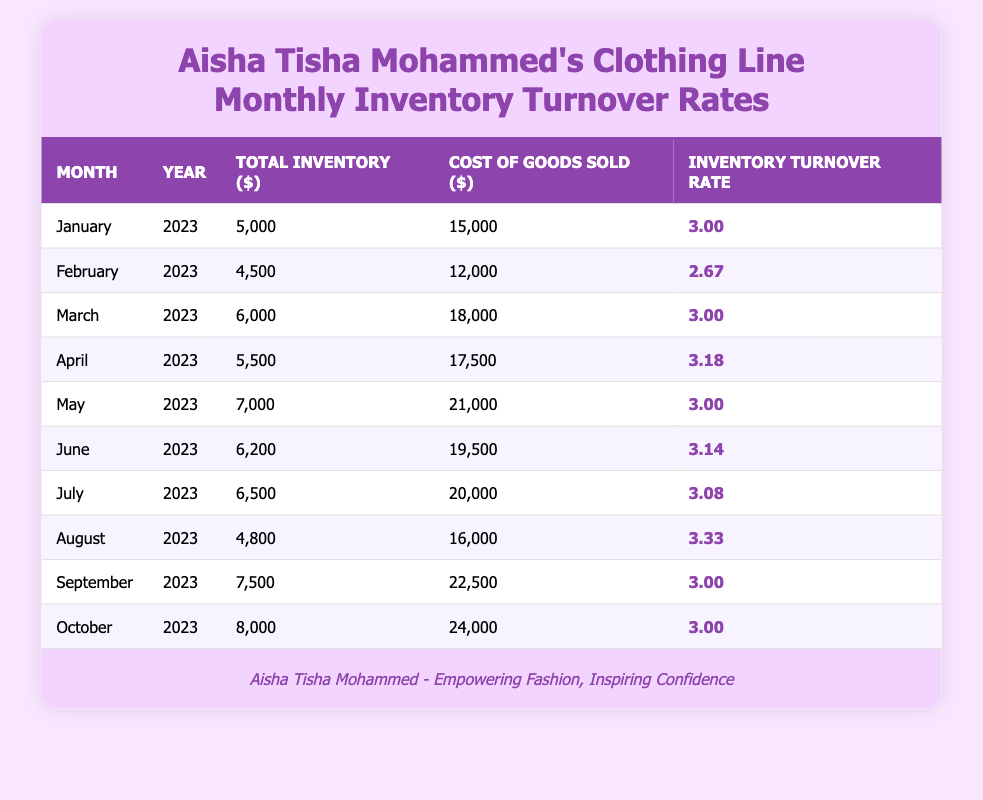What was the total inventory in June 2023? In the table, the row for June 2023 shows a total inventory of 6200.
Answer: 6200 Which month had the highest inventory turnover rate? Reviewing the table shows that August 2023 had the highest inventory turnover rate at 3.33.
Answer: 3.33 What is the average inventory turnover rate for the first quarter of 2023? The first quarter includes January (3.00), February (2.67), and March (3.00). The average is (3.00 + 2.67 + 3.00) / 3 = 2.89.
Answer: 2.89 Did Aisha Tisha Mohammed's clothing line maintain an inventory turnover rate of 3.0 in April 2023? Checking the table for April 2023 shows an inventory turnover rate of 3.18, which is greater than 3.0.
Answer: No How many months had an inventory turnover rate greater than 3.0? From the table, the months with an inventory turnover rate above 3.0 are January, March, April, June, July, and August. There are 6 months total.
Answer: 6 What was the cost of goods sold in September 2023? The table lists the cost of goods sold in September 2023 as 22500.
Answer: 22500 Calculate the total inventory across all months. Summing the total inventory for each month gives us: 5000 + 4500 + 6000 + 5500 + 7000 + 6200 + 6500 + 4800 + 7500 + 8000 = 58500.
Answer: 58500 Was the total inventory in May 2023 higher than in January 2023? Comparing the total inventory values, May 2023 (7000) is higher than January 2023 (5000).
Answer: Yes 